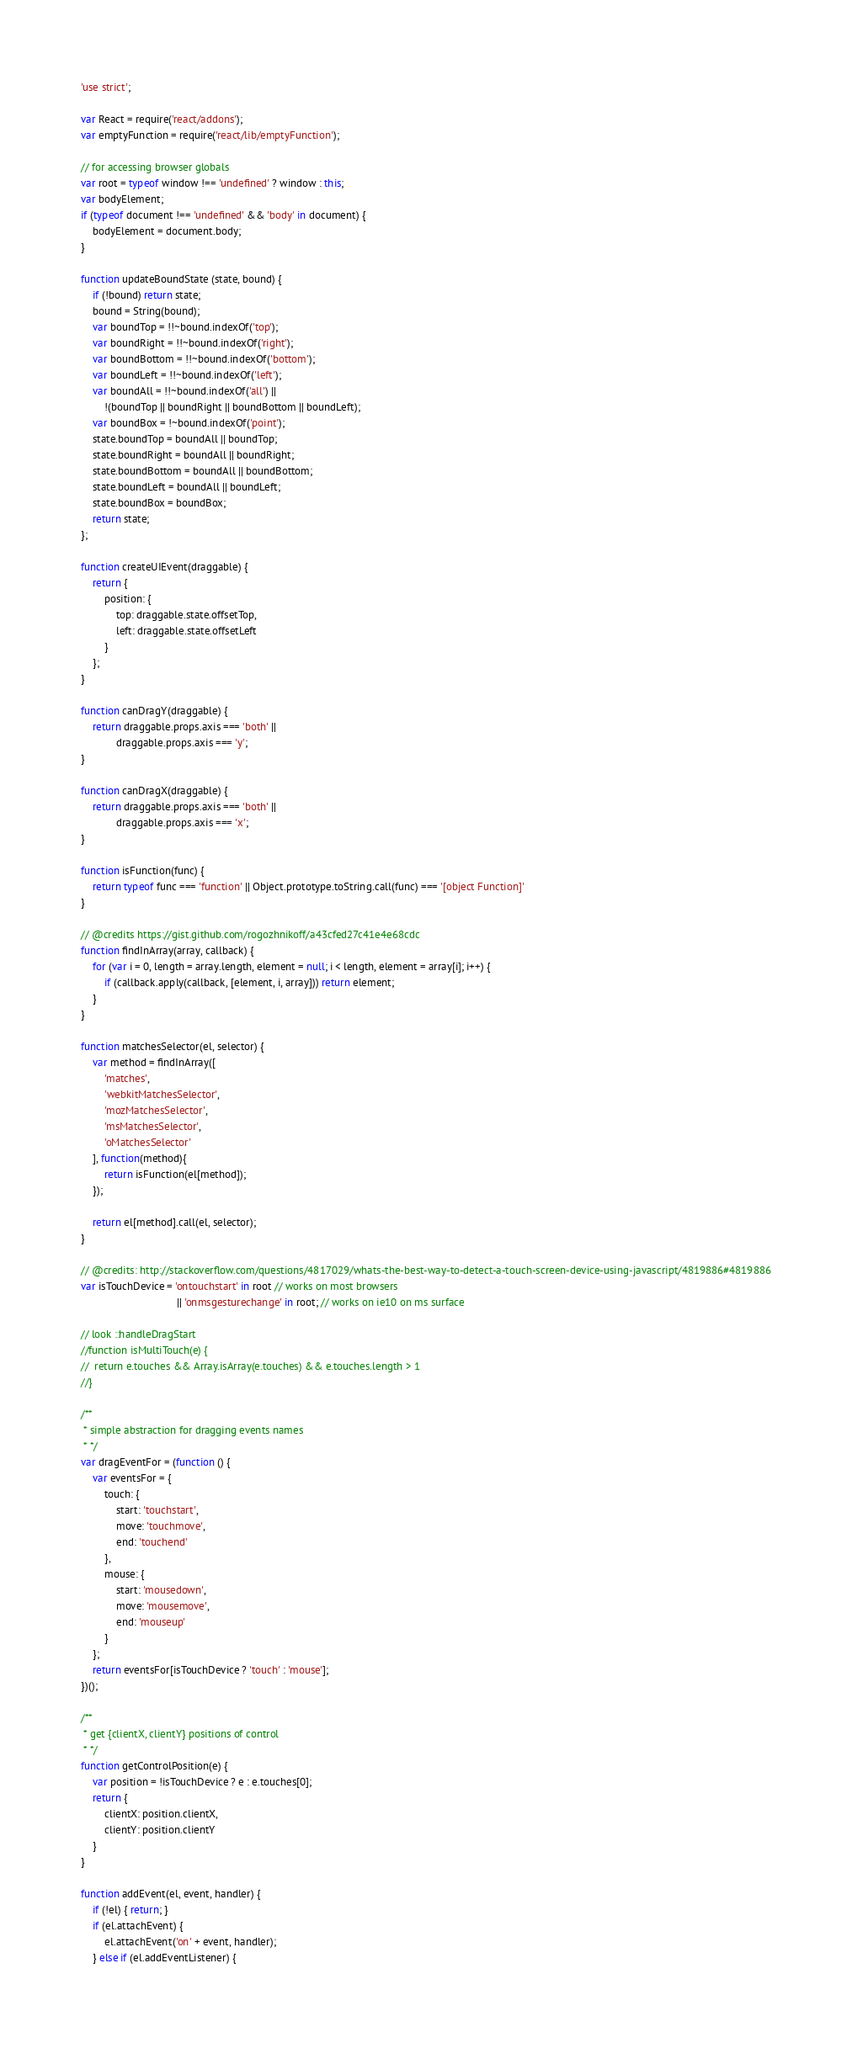Convert code to text. <code><loc_0><loc_0><loc_500><loc_500><_JavaScript_>'use strict';

var React = require('react/addons');
var emptyFunction = require('react/lib/emptyFunction');

// for accessing browser globals
var root = typeof window !== 'undefined' ? window : this;
var bodyElement;
if (typeof document !== 'undefined' && 'body' in document) {
	bodyElement = document.body;
}

function updateBoundState (state, bound) {
	if (!bound) return state;
	bound = String(bound);
	var boundTop = !!~bound.indexOf('top');
	var boundRight = !!~bound.indexOf('right');
	var boundBottom = !!~bound.indexOf('bottom');
	var boundLeft = !!~bound.indexOf('left');
	var boundAll = !!~bound.indexOf('all') ||
		!(boundTop || boundRight || boundBottom || boundLeft);
	var boundBox = !~bound.indexOf('point');
	state.boundTop = boundAll || boundTop;
	state.boundRight = boundAll || boundRight;
	state.boundBottom = boundAll || boundBottom;
	state.boundLeft = boundAll || boundLeft;
	state.boundBox = boundBox;
	return state;
};

function createUIEvent(draggable) {
	return {
		position: {
			top: draggable.state.offsetTop,
			left: draggable.state.offsetLeft
		}
	};
}

function canDragY(draggable) {
	return draggable.props.axis === 'both' ||
			draggable.props.axis === 'y';
}

function canDragX(draggable) {
	return draggable.props.axis === 'both' ||
			draggable.props.axis === 'x';
}

function isFunction(func) {
	return typeof func === 'function' || Object.prototype.toString.call(func) === '[object Function]'
}

// @credits https://gist.github.com/rogozhnikoff/a43cfed27c41e4e68cdc
function findInArray(array, callback) {
	for (var i = 0, length = array.length, element = null; i < length, element = array[i]; i++) {
		if (callback.apply(callback, [element, i, array])) return element;
	}
}

function matchesSelector(el, selector) {
	var method = findInArray([
		'matches',
		'webkitMatchesSelector',
		'mozMatchesSelector',
		'msMatchesSelector',
		'oMatchesSelector'
	], function(method){
		return isFunction(el[method]);
	});

	return el[method].call(el, selector);
}

// @credits: http://stackoverflow.com/questions/4817029/whats-the-best-way-to-detect-a-touch-screen-device-using-javascript/4819886#4819886
var isTouchDevice = 'ontouchstart' in root // works on most browsers
								 || 'onmsgesturechange' in root; // works on ie10 on ms surface

// look ::handleDragStart
//function isMultiTouch(e) {
//  return e.touches && Array.isArray(e.touches) && e.touches.length > 1
//}

/**
 * simple abstraction for dragging events names
 * */
var dragEventFor = (function () {
	var eventsFor = {
		touch: {
			start: 'touchstart',
			move: 'touchmove',
			end: 'touchend'
		},
		mouse: {
			start: 'mousedown',
			move: 'mousemove',
			end: 'mouseup'
		}
	};
	return eventsFor[isTouchDevice ? 'touch' : 'mouse'];
})();

/**
 * get {clientX, clientY} positions of control
 * */
function getControlPosition(e) {
	var position = !isTouchDevice ? e : e.touches[0];
	return {
		clientX: position.clientX,
		clientY: position.clientY
	}
}

function addEvent(el, event, handler) {
	if (!el) { return; }
	if (el.attachEvent) {
		el.attachEvent('on' + event, handler);
	} else if (el.addEventListener) {</code> 